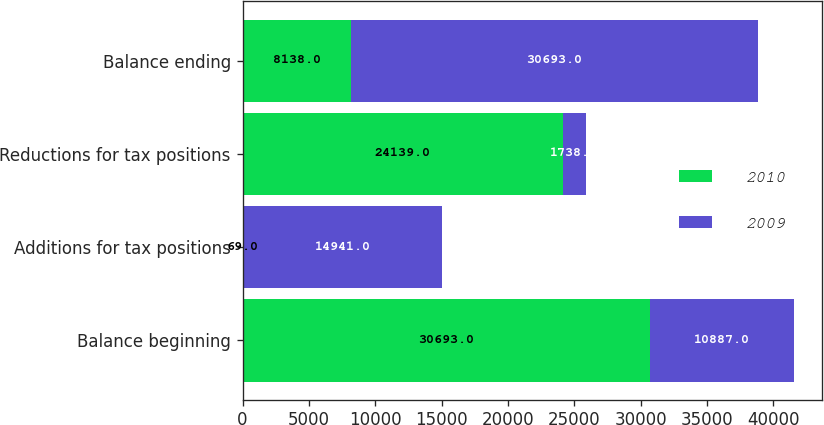<chart> <loc_0><loc_0><loc_500><loc_500><stacked_bar_chart><ecel><fcel>Balance beginning<fcel>Additions for tax positions<fcel>Reductions for tax positions<fcel>Balance ending<nl><fcel>2010<fcel>30693<fcel>69<fcel>24139<fcel>8138<nl><fcel>2009<fcel>10887<fcel>14941<fcel>1738<fcel>30693<nl></chart> 